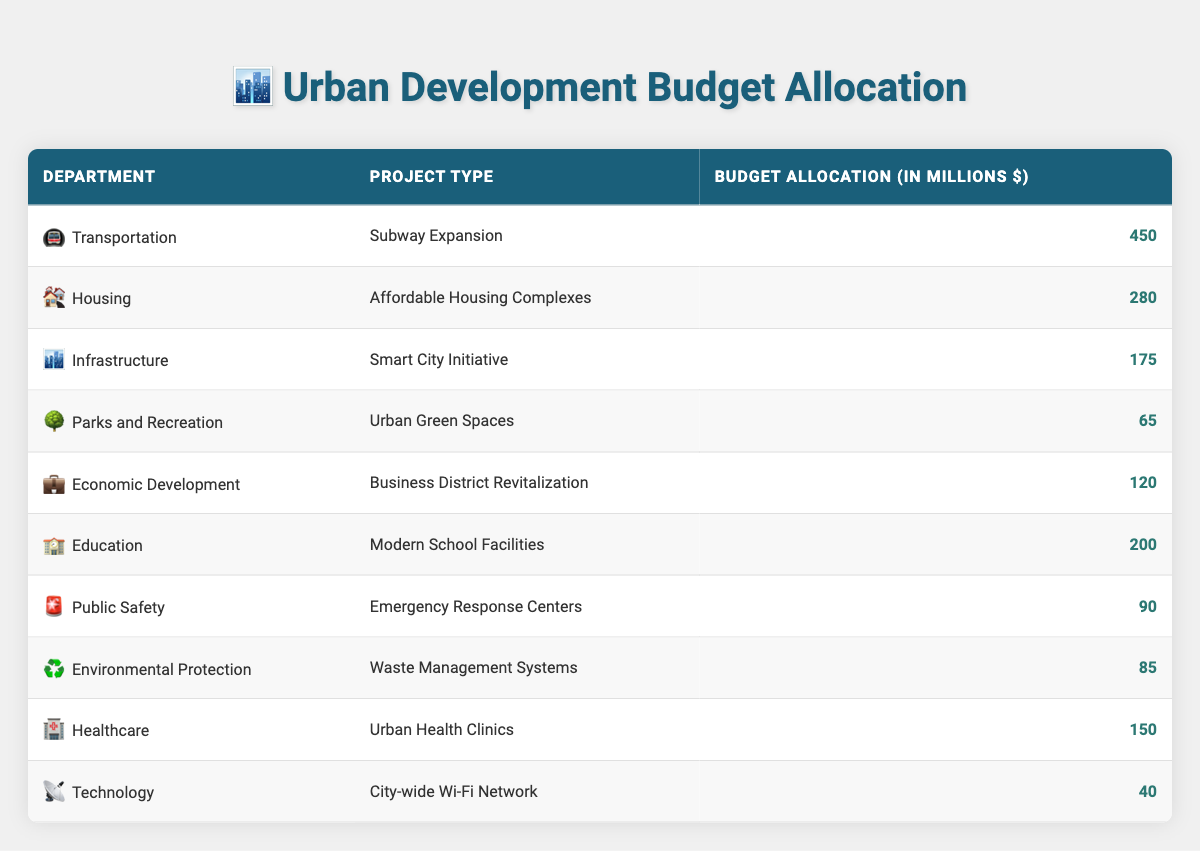What is the total budget allocation for the Transportation department? The table shows that the budget allocation for the Transportation department for the Subway Expansion project is 450 million dollars. Therefore, the total allocation for this department is simply 450 million dollars.
Answer: 450 million dollars Which department has the lowest budget allocation? By examining the budget allocations listed, the Technology department has the lowest allocation of 40 million dollars for the City-wide Wi-Fi Network project compared to the other departments.
Answer: Technology department What is the combined budget allocation for Education and Housing departments? The budget allocation for Education (Modern School Facilities) is 200 million dollars, and for Housing (Affordable Housing Complexes), it's 280 million dollars. To find the combined total, we add these two amounts: 200 + 280 = 480 million dollars.
Answer: 480 million dollars Is the budget allocation for Parks and Recreation greater than the budget for Emergency Response Centers? The Parks and Recreation budget for Urban Green Spaces is 65 million dollars, while the Public Safety budget for Emergency Response Centers is 90 million dollars. Since 65 is less than 90, the statement is false.
Answer: No What is the average budget allocation across all departments? To calculate the average, first sum all the budget allocations: 450 + 280 + 175 + 65 + 120 + 200 + 90 + 85 + 150 + 40 = 1,610 million dollars. There are 10 departments, so to find the average, divide the total by the number of departments: 1,610 / 10 = 161 million dollars.
Answer: 161 million dollars Which project type in the Infrastructure department has a budget allocation that is less than the Healthcare allocation? The table indicates that the Infrastructure department's Smart City Initiative has a budget allocation of 175 million dollars, while the Healthcare department's Urban Health Clinics allocation is 150 million dollars. Since 175 million is greater than 150 million, the answer is: there is no project in Infrastructure with a lower budget allocation than the Healthcare allocation of 150 million dollars.
Answer: No What is the difference in budget allocation between the Housing and Economic Development departments? The Housing department's budget is 280 million dollars for Affordable Housing Complexes, while Economic Development's budget is 120 million dollars for Business District Revitalization. To find the difference, subtract the Economic Development budget from the Housing budget: 280 - 120 = 160 million dollars.
Answer: 160 million dollars How many departments have a budget allocation above 100 million dollars? By inspecting the table, the Departments with allocations above 100 million dollars are Transportation (450), Housing (280), Infrastructure (175), Education (200), Healthcare (150), and Economic Development (120). Therefore, there are 6 departments with allocations above 100 million dollars.
Answer: 6 departments 